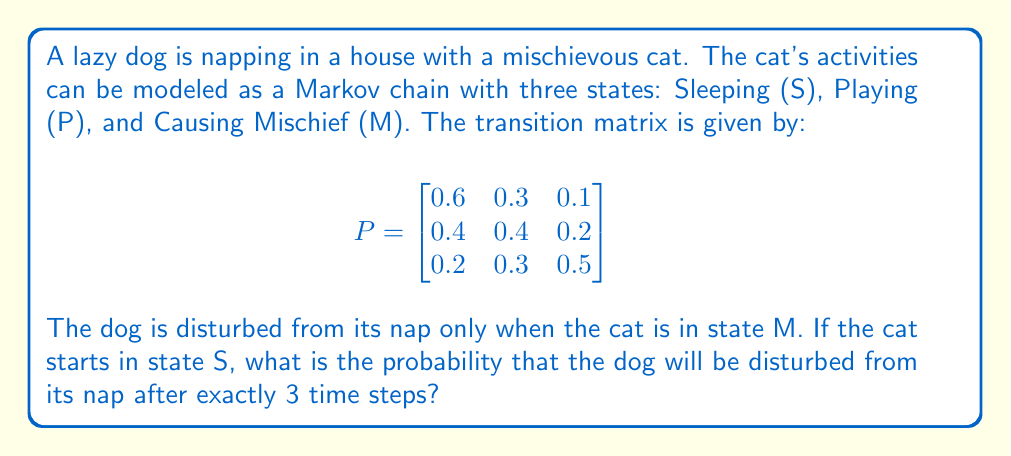Solve this math problem. To solve this problem, we need to use the Markov chain transition matrix and calculate the probability of being in state M after 3 steps, starting from state S. We can do this by raising the transition matrix to the power of 3 and looking at the entry corresponding to the transition from S to M.

Step 1: Calculate $P^3$
$$ P^3 = P \times P \times P $$

We can use matrix multiplication or a computer algebra system to calculate this. The result is:

$$ P^3 = \begin{bmatrix}
0.456 & 0.324 & 0.220 \\
0.416 & 0.336 & 0.248 \\
0.368 & 0.324 & 0.308
\end{bmatrix} $$

Step 2: Identify the probability of transitioning from S to M in 3 steps
The probability we're looking for is in the first row (starting state S) and third column (ending state M) of $P^3$. This value is 0.220.

Therefore, the probability that the dog will be disturbed from its nap after exactly 3 time steps, given that the cat starts in state S, is 0.220 or 22%.
Answer: 0.220 